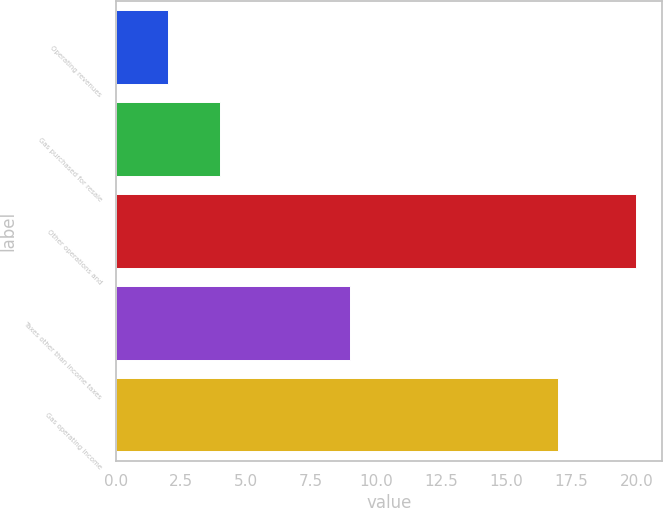<chart> <loc_0><loc_0><loc_500><loc_500><bar_chart><fcel>Operating revenues<fcel>Gas purchased for resale<fcel>Other operations and<fcel>Taxes other than income taxes<fcel>Gas operating income<nl><fcel>2<fcel>4<fcel>20<fcel>9<fcel>17<nl></chart> 